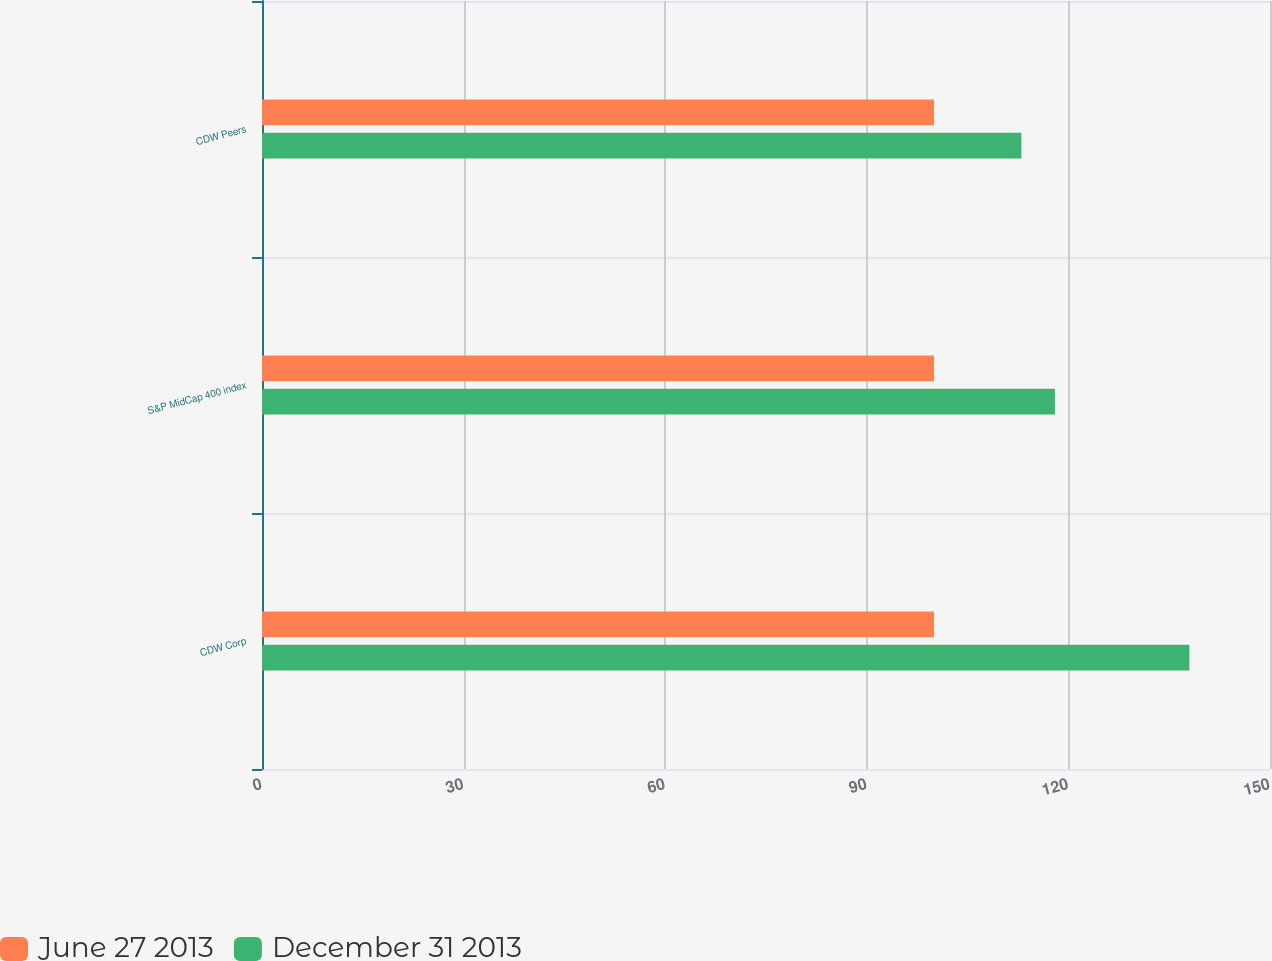Convert chart to OTSL. <chart><loc_0><loc_0><loc_500><loc_500><stacked_bar_chart><ecel><fcel>CDW Corp<fcel>S&P MidCap 400 index<fcel>CDW Peers<nl><fcel>June 27 2013<fcel>100<fcel>100<fcel>100<nl><fcel>December 31 2013<fcel>138<fcel>118<fcel>113<nl></chart> 